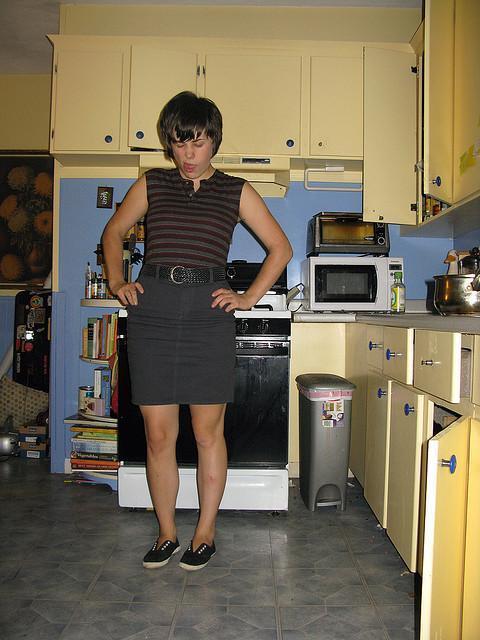How many ovens are there?
Give a very brief answer. 2. How many donuts are in the last row?
Give a very brief answer. 0. 